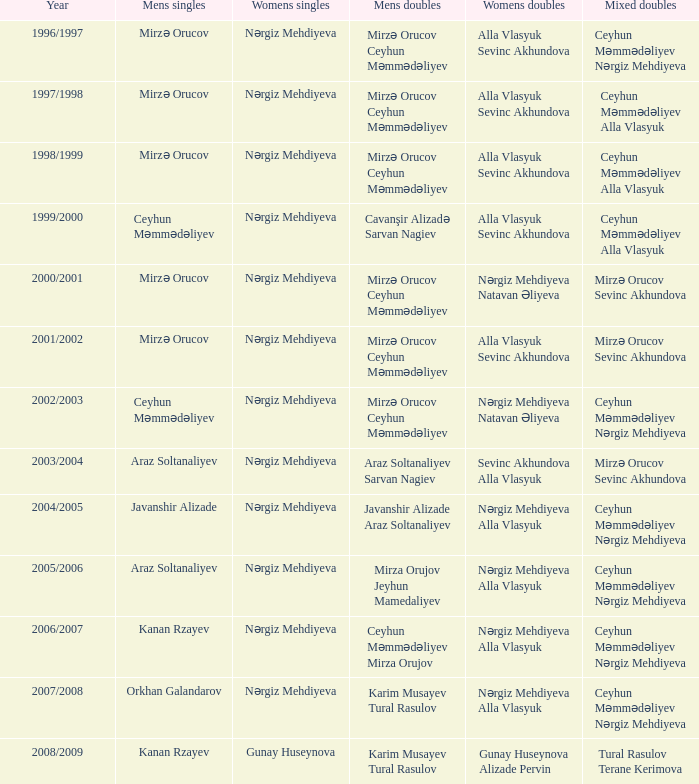Who are all the womens doubles for the year 2008/2009? Gunay Huseynova Alizade Pervin. 